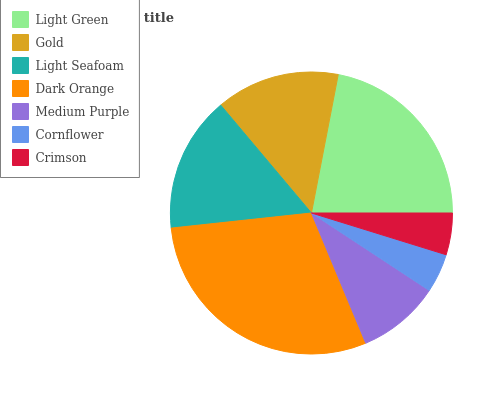Is Cornflower the minimum?
Answer yes or no. Yes. Is Dark Orange the maximum?
Answer yes or no. Yes. Is Gold the minimum?
Answer yes or no. No. Is Gold the maximum?
Answer yes or no. No. Is Light Green greater than Gold?
Answer yes or no. Yes. Is Gold less than Light Green?
Answer yes or no. Yes. Is Gold greater than Light Green?
Answer yes or no. No. Is Light Green less than Gold?
Answer yes or no. No. Is Gold the high median?
Answer yes or no. Yes. Is Gold the low median?
Answer yes or no. Yes. Is Crimson the high median?
Answer yes or no. No. Is Light Seafoam the low median?
Answer yes or no. No. 